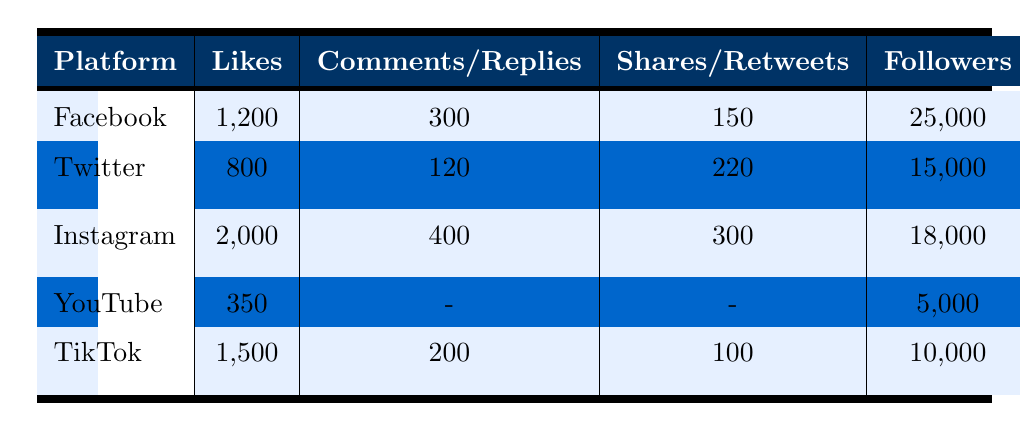What is the engagement rate for Instagram? The engagement rate for Instagram can be found directly in the table under the "Engagement Rate" column for the Instagram row, which shows 11%.
Answer: 11% Which platform had the highest number of likes? By comparing the "Likes" column for each platform, Instagram has the highest number of likes at 2000.
Answer: Instagram How many total comments/replies were received across all platforms? To find the total comments/replies, we sum the comments from Facebook (300), Twitter (120), Instagram (400), TikTok (200), and YouTube (0), which equals 300 + 120 + 400 + 200 + 0 = 1020.
Answer: 1020 Is the top post for Facebook related to a game victory? The top post for Facebook is "Team wins championship!", which indicates a game victory. Thus, the statement is true.
Answer: Yes Which platform has the lowest number of followers? By checking the "Followers" column, YouTube has the lowest number with 5000 followers.
Answer: YouTube What is the average engagement rate of all platforms? We find the engagement rates: Facebook (6%), Twitter (8%), Instagram (11%), YouTube (7%), TikTok (9%). Summing these up gives 6 + 8 + 11 + 7 + 9 = 41. Then, we divide by the number of platforms (5): 41/5 = 8.2%.
Answer: 8.2% Which platform had the most shares? The shares are compared from the "Shares/Retweets" column, and Instagram had the most at 300 shares.
Answer: Instagram Is TikTok's engagement rate higher than Facebook's? TikTok's engagement rate is 9%, while Facebook's is 6%. Since 9% is greater than 6%, the statement is true.
Answer: Yes How many videos/posts in total did YouTube and Instagram have combined? YouTube has one video ("Team's journey to the finals"), and Instagram has one post ("Behind-the-scenes practice session"). Therefore, combined they have 1 + 1 = 2.
Answer: 2 What proportion of total likes does Facebook account for? Facebook has 1200 likes. Total likes from all platforms are 2000 (Instagram) + 1500 (TikTok) + 800 (Twitter) + 350 (YouTube) + 1200 (Facebook) = 4850. The proportion is 1200/4850, which simplifies to approximately 24.7%.
Answer: 24.7% 